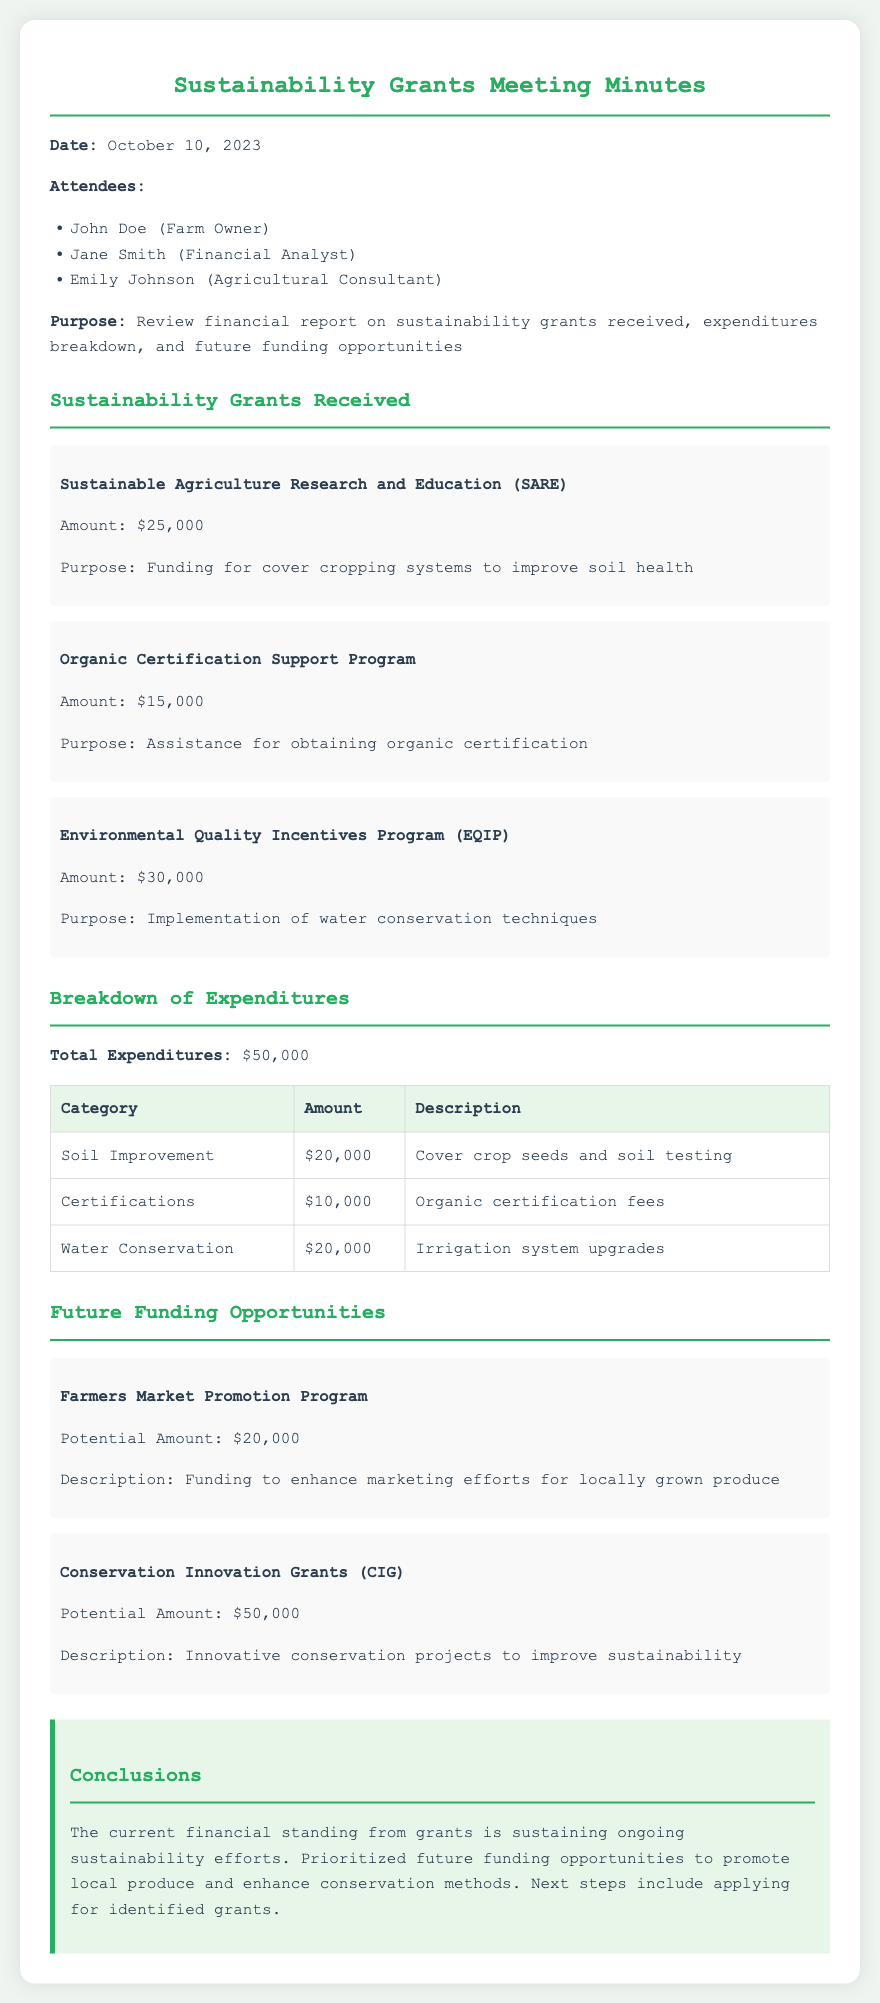What is the date of the meeting? The date of the meeting is stated in the document, which is October 10, 2023.
Answer: October 10, 2023 Who is the financial analyst present at the meeting? The document lists attendees, including the financial analyst, whose name is Jane Smith.
Answer: Jane Smith What is the amount received from the SARE grant? The document specifies the grant amount received from the Sustainable Agriculture Research and Education (SARE) program, which is $25,000.
Answer: $25,000 What was the total expenditure reported? The total expenditures are clearly outlined in the document, indicating a sum of $50,000.
Answer: $50,000 How much is allocated for water conservation measures? The breakdown of expenditures highlights the amount allocated for water conservation, which is $20,000.
Answer: $20,000 What is the potential amount for the Farmers Market Promotion Program? The potential funding amount for the Farmers Market Promotion Program is mentioned in the future funding opportunities section and is $20,000.
Answer: $20,000 What is the total amount of grants received? By adding all the grants listed in the document, the total amount shows to be $70,000 ($25,000 + $15,000 + $30,000).
Answer: $70,000 What are the future funding opportunities focused on? The future funding opportunities discussion highlights promoting local produce and improving sustainability through conservation methods.
Answer: Local produce and sustainability Who summarized the conclusions of the meeting? The document does not specifically name a person who summarized the conclusions; it is inferred to be a collective effort from the attendees.
Answer: Not specified 